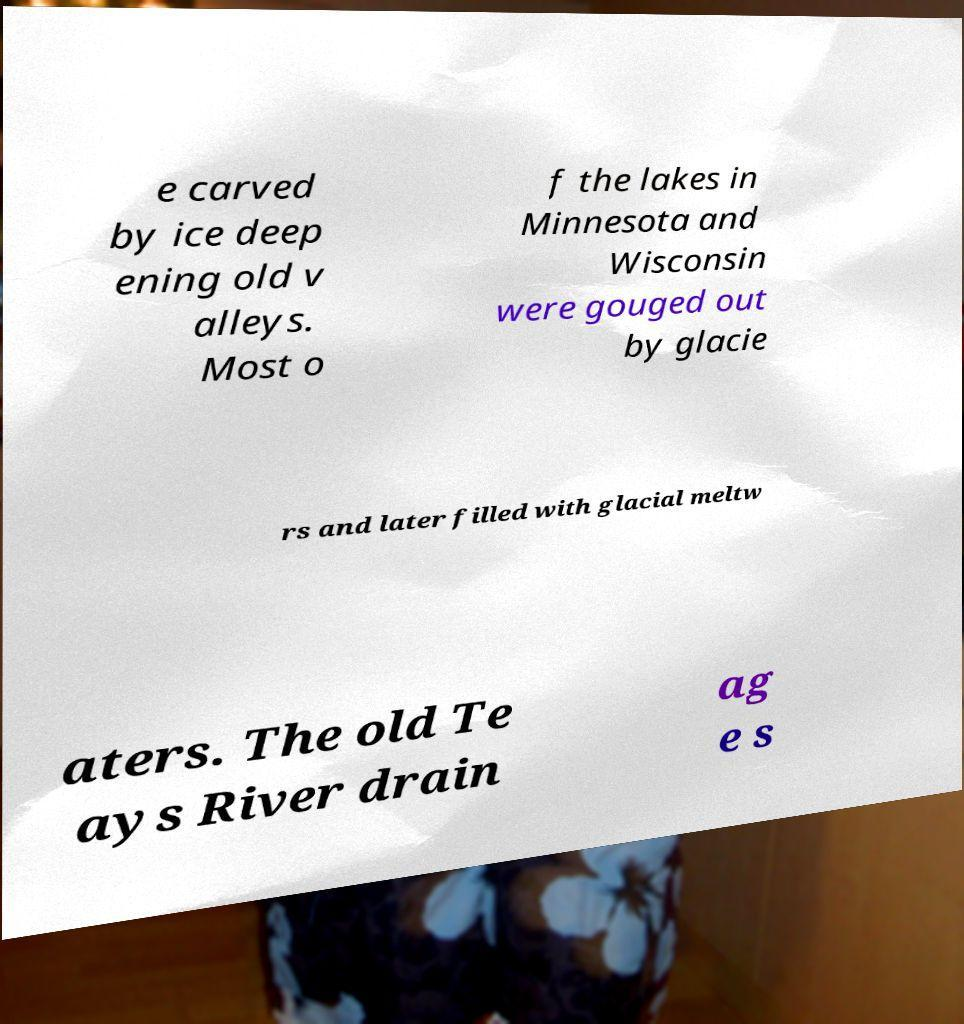What messages or text are displayed in this image? I need them in a readable, typed format. e carved by ice deep ening old v alleys. Most o f the lakes in Minnesota and Wisconsin were gouged out by glacie rs and later filled with glacial meltw aters. The old Te ays River drain ag e s 